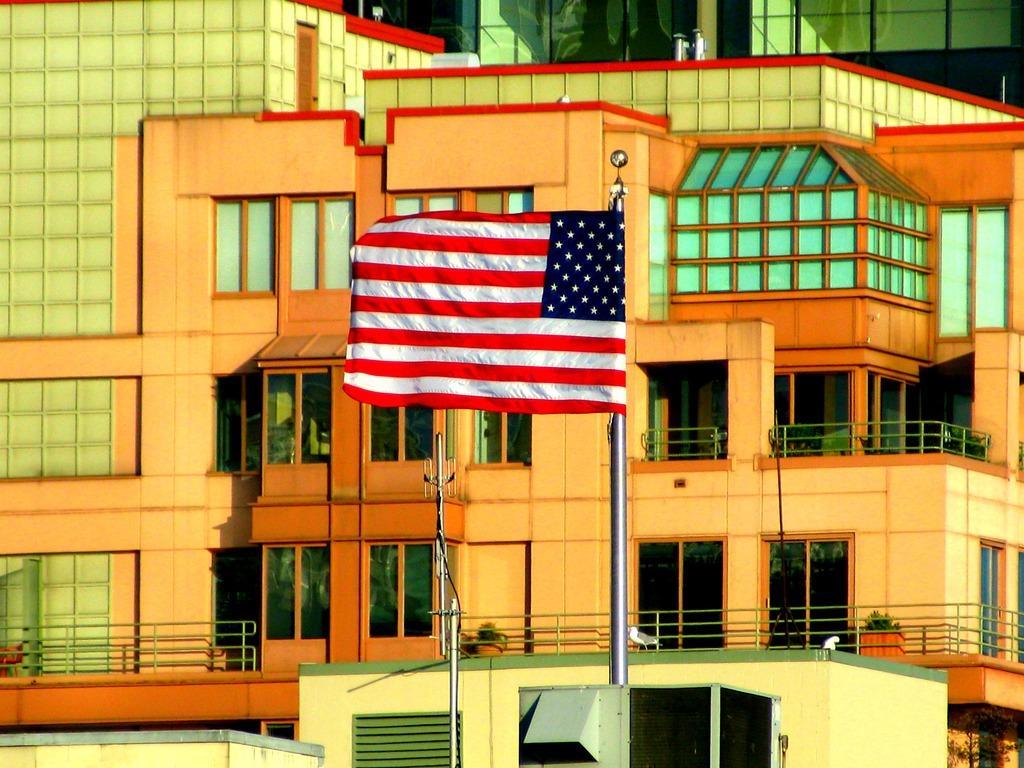In one or two sentences, can you explain what this image depicts? In this image there is a flag as we can see in middle of this image and there are some poles at bottom of this image and there is a building in the background. 